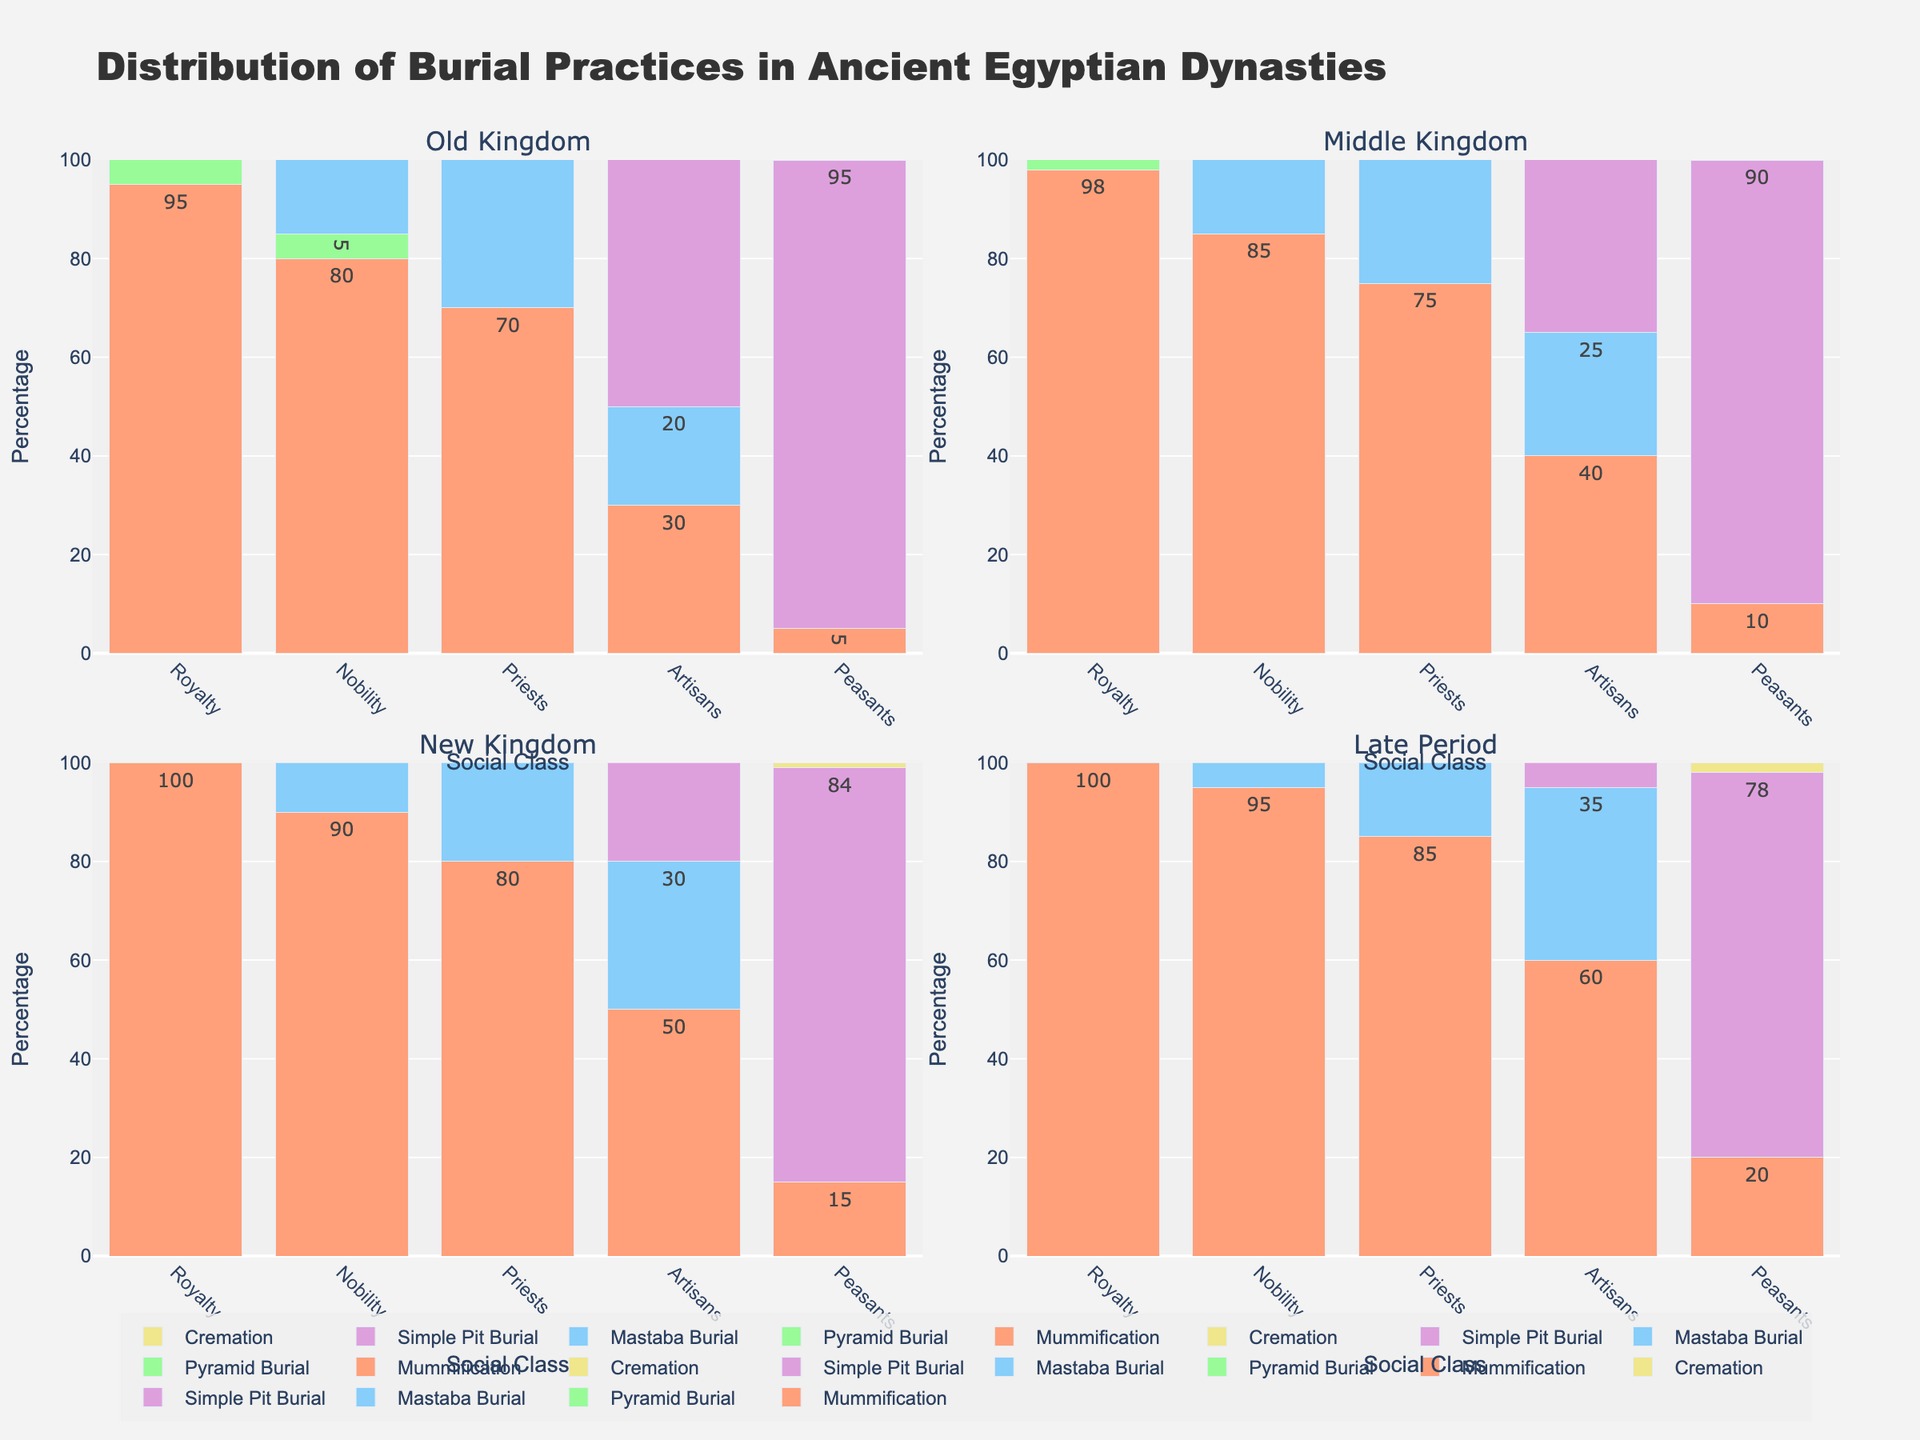What is the most common burial practice for royalty in the New Kingdom? To find the most common burial practice for royalty in the New Kingdom, look at the height of the bars in the New Kingdom section labeled "Royalty" and compare their values. The tallest bar corresponds to Mummification with a 100% value.
Answer: Mummification Which social class has the highest percentage of Simple Pit Burial in the Old Kingdom? Examine the Old Kingdom subplot and check the heights of the Simple Pit Burial bars for each social class. The Peasants have the highest bar with a value of 95%.
Answer: Peasants What is the total percentage of Mastaba Burial for priests across all dynasties? Look at the Mastaba Burial percentages for Priests in each dynasty: Old Kingdom (60), Middle Kingdom (65), New Kingdom (70), Late Period (75). Sum these values: 60 + 65 + 70 + 75 = 270.
Answer: 270% Which dynasty shows the least variation in burial practices for Artisans? Compare the heights of different practice bars for Artisans across all dynasties. The Old Kingdom shows a larger spread (30 for Mummification, 20 for Mastaba Burial, 75 for Simple Pit Burial). The Middle Kingdom, New Kingdom, and Late Period have less variation. Hence, the Middle Kingdom (40 for Mummification, 25 for Mastaba Burial, 70 for Simple Pit Burial) displays less overall variation.
Answer: Middle Kingdom What is the difference in the percentage of Cremation between Artisans and Peasants in the Late Period? Check the Late Period subplot for Cremation values: Artisans (2) and Peasants (2). Subtract these to find the difference: 2 - 2 = 0.
Answer: 0 Are there any social classes that did not practice Pyramid Burial at all in the Middle Kingdom? Look at the Pyramid Burial bars in the Middle Kingdom section. The Nobility, Priests, Artisans, and Peasants have bars with a value of 0, indicating they did not practice Pyramid Burial.
Answer: Yes What is the average percentage of Mummification practices among Nobility across all dynasties? Check the Mummification percentages for Nobility in each dynasty: Old Kingdom (80), Middle Kingdom (85), New Kingdom (90), Late Period (95). Calculate the average: (80 + 85 + 90 + 95) / 4 = 87.5.
Answer: 87.5 How does the percentage of Pyramid Burial for Royalty change from the Old Kingdom to the New Kingdom? Compare the Pyramid Burial percentages for Royalty: Old Kingdom (90), New Kingdom (10). Calculate the difference: 90 - 10 = 80.
Answer: Decreases by 80 Which burial practice shows the greatest variation in percentage among Peasants in the New Kingdom? Look at the heights of the bars for Peasants in the New Kingdom section. Observe the differences between Mummification (15), Simple Pit Burial (84), Cremation (1). The highest difference is between Simple Pit Burial and Cremation: 84 - 1 = 83.
Answer: Simple Pit Burial 